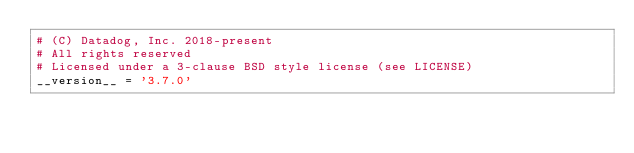<code> <loc_0><loc_0><loc_500><loc_500><_Python_># (C) Datadog, Inc. 2018-present
# All rights reserved
# Licensed under a 3-clause BSD style license (see LICENSE)
__version__ = '3.7.0'
</code> 